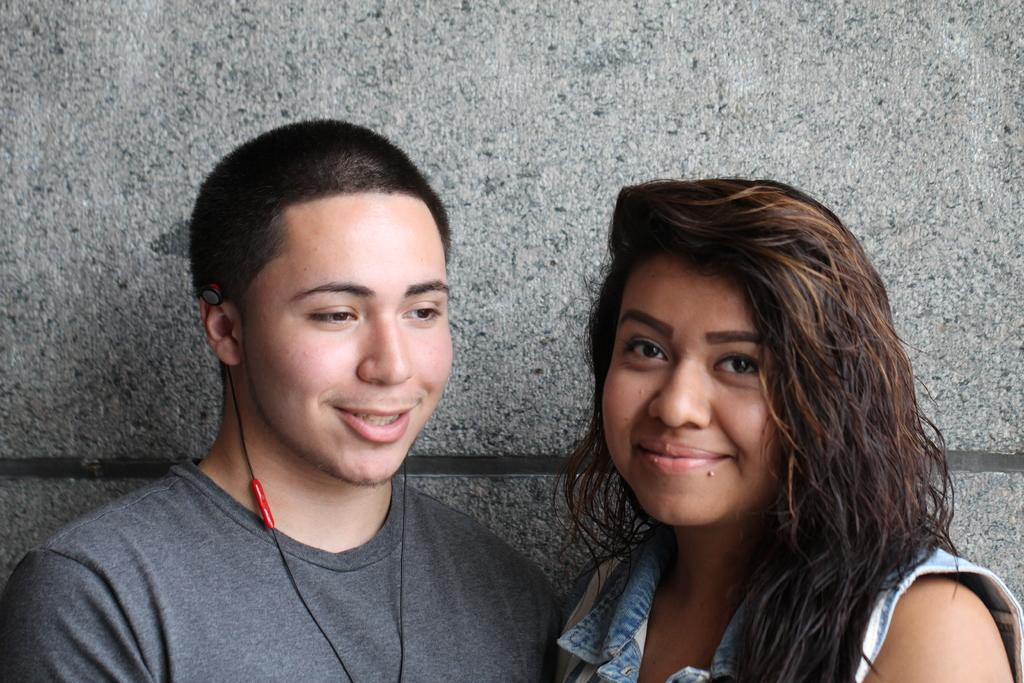Who are the people in the image? There is a man and a woman in the image. What expressions do the people in the image have? Both the man and the woman are smiling. What can be seen in the background of the image? There is a wall in the background of the image. What type of vehicle is the man driving in the image? There is no vehicle present in the image, and the man is not driving. 